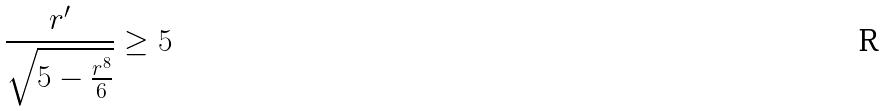<formula> <loc_0><loc_0><loc_500><loc_500>\frac { r ^ { \prime } } { \sqrt { 5 - \frac { r ^ { 8 } } { 6 } } } \geq 5</formula> 